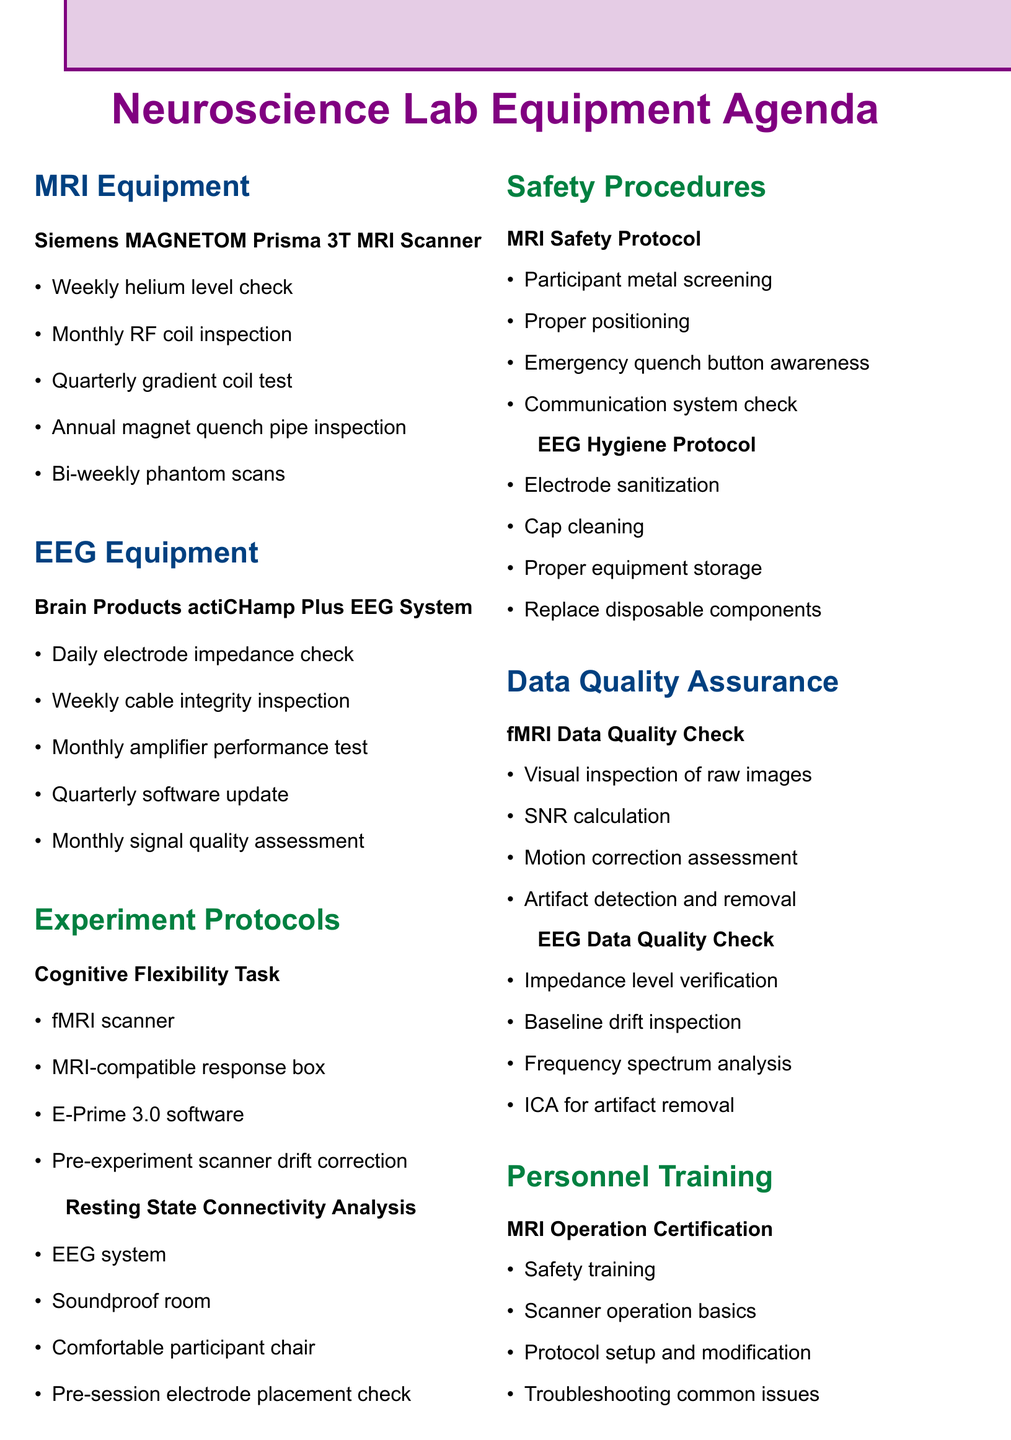What is the name of the fMRI scanner? The fMRI scanner is referenced in the document and is named as "Siemens MAGNETOM Prisma 3T MRI Scanner".
Answer: Siemens MAGNETOM Prisma 3T MRI Scanner How often is the RF coil inspected? The document states that the RF coil is inspected on a monthly basis.
Answer: Monthly What is the calibration schedule for the EEG system? The EEG system's calibration schedule is detailed in the document as being assessed monthly using known input signals.
Answer: Monthly signal quality assessment What is required for the Cognitive Flexibility Task experiment? The document lists multiple requirements for the Cognitive Flexibility Task experiment, including the fMRI scanner and MRI-compatible response box, among others.
Answer: fMRI scanner How frequently should a software update be performed for the EEG system? In the document, it is mentioned that the EEG system requires a software update quarterly.
Answer: Quarterly What is the first step in the MRI Safety Protocol? According to the safety procedures outlined in the document, the first step involves screening participants for metal objects.
Answer: Participant screening for metal objects What is the primary focus of the Multi-site Cognitive Flexibility Study? The document indicates that the partnership for this study includes institutions with an emphasis on cognitive flexibility.
Answer: Cognitive Flexibility Study How often should phantom scans be performed on the fMRI scanner? The document specifies that phantom scans for quality assurance on the fMRI scanner are conducted bi-weekly.
Answer: Bi-weekly What type of training is required before operating the MRI scanner? The document lists several components of training, but specifically, it highlights the importance of safety training.
Answer: Safety training 